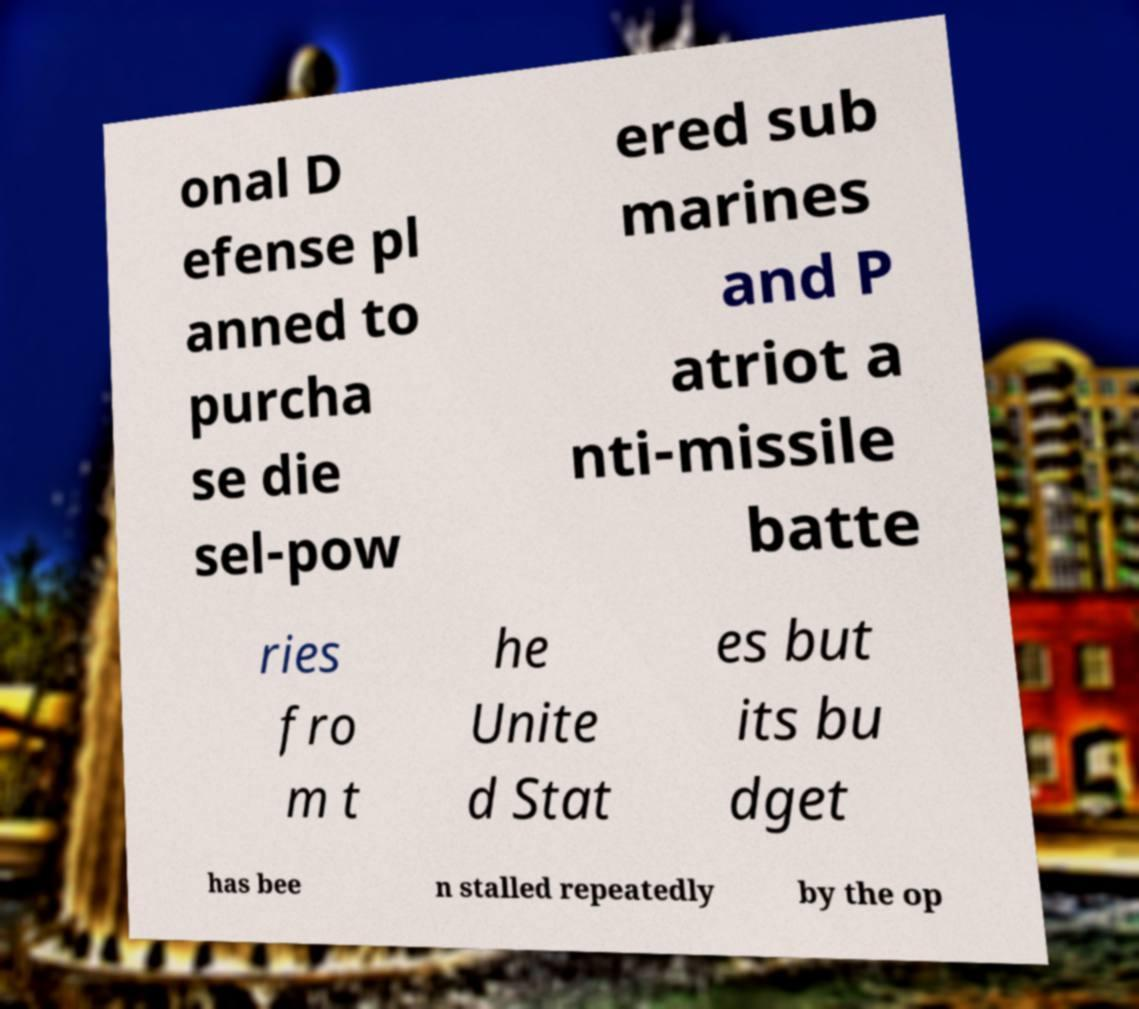For documentation purposes, I need the text within this image transcribed. Could you provide that? onal D efense pl anned to purcha se die sel-pow ered sub marines and P atriot a nti-missile batte ries fro m t he Unite d Stat es but its bu dget has bee n stalled repeatedly by the op 